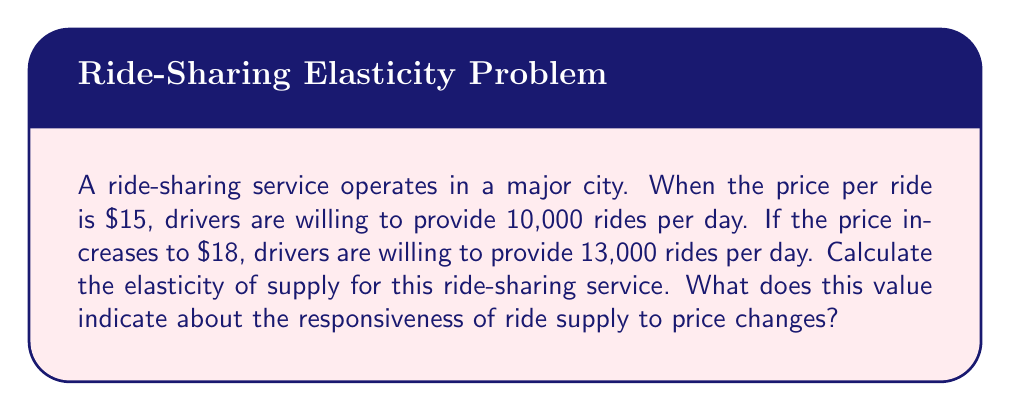Provide a solution to this math problem. To calculate the elasticity of supply, we'll use the following formula:

$$ E_s = \frac{\text{Percentage change in quantity supplied}}{\text{Percentage change in price}} $$

Let's break this down step-by-step:

1) Calculate the percentage change in quantity supplied:
   Initial quantity: 10,000 rides
   New quantity: 13,000 rides
   
   $\text{Percentage change} = \frac{13,000 - 10,000}{10,000} \times 100 = 30\%$

2) Calculate the percentage change in price:
   Initial price: $15
   New price: $18
   
   $\text{Percentage change} = \frac{18 - 15}{15} \times 100 = 20\%$

3) Now, let's plug these values into our elasticity formula:

   $$ E_s = \frac{30\%}{20\%} = 1.5 $$

The elasticity of supply is 1.5, which means that for every 1% increase in price, there is a 1.5% increase in the quantity of rides supplied.

This value indicates that the supply of rides is relatively elastic (E_s > 1). It suggests that drivers are quite responsive to price changes, likely because they can easily enter or exit the market or adjust their working hours based on the potential earnings.
Answer: The elasticity of supply for the ride-sharing service is 1.5, indicating a relatively elastic supply where drivers are responsive to price changes. 